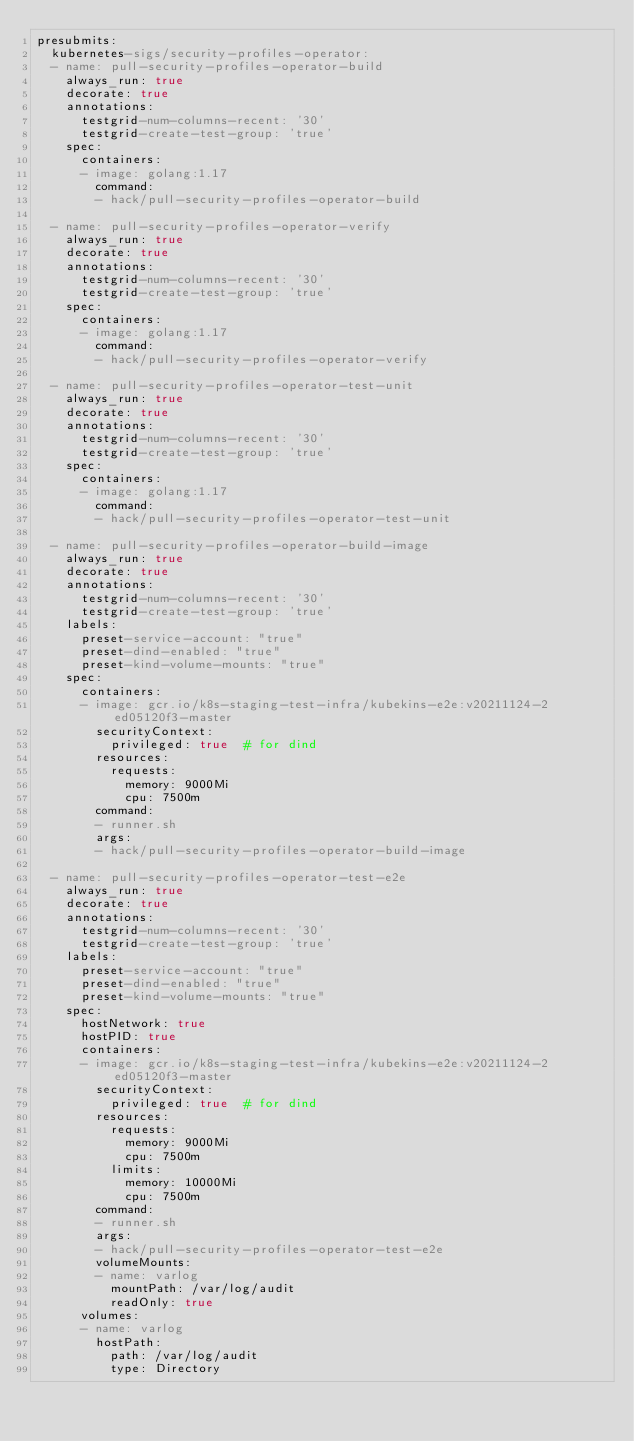Convert code to text. <code><loc_0><loc_0><loc_500><loc_500><_YAML_>presubmits:
  kubernetes-sigs/security-profiles-operator:
  - name: pull-security-profiles-operator-build
    always_run: true
    decorate: true
    annotations:
      testgrid-num-columns-recent: '30'
      testgrid-create-test-group: 'true'
    spec:
      containers:
      - image: golang:1.17
        command:
        - hack/pull-security-profiles-operator-build

  - name: pull-security-profiles-operator-verify
    always_run: true
    decorate: true
    annotations:
      testgrid-num-columns-recent: '30'
      testgrid-create-test-group: 'true'
    spec:
      containers:
      - image: golang:1.17
        command:
        - hack/pull-security-profiles-operator-verify

  - name: pull-security-profiles-operator-test-unit
    always_run: true
    decorate: true
    annotations:
      testgrid-num-columns-recent: '30'
      testgrid-create-test-group: 'true'
    spec:
      containers:
      - image: golang:1.17
        command:
        - hack/pull-security-profiles-operator-test-unit

  - name: pull-security-profiles-operator-build-image
    always_run: true
    decorate: true
    annotations:
      testgrid-num-columns-recent: '30'
      testgrid-create-test-group: 'true'
    labels:
      preset-service-account: "true"
      preset-dind-enabled: "true"
      preset-kind-volume-mounts: "true"
    spec:
      containers:
      - image: gcr.io/k8s-staging-test-infra/kubekins-e2e:v20211124-2ed05120f3-master
        securityContext:
          privileged: true  # for dind
        resources:
          requests:
            memory: 9000Mi
            cpu: 7500m
        command:
        - runner.sh
        args:
        - hack/pull-security-profiles-operator-build-image

  - name: pull-security-profiles-operator-test-e2e
    always_run: true
    decorate: true
    annotations:
      testgrid-num-columns-recent: '30'
      testgrid-create-test-group: 'true'
    labels:
      preset-service-account: "true"
      preset-dind-enabled: "true"
      preset-kind-volume-mounts: "true"
    spec:
      hostNetwork: true
      hostPID: true
      containers:
      - image: gcr.io/k8s-staging-test-infra/kubekins-e2e:v20211124-2ed05120f3-master
        securityContext:
          privileged: true  # for dind
        resources:
          requests:
            memory: 9000Mi
            cpu: 7500m
          limits:
            memory: 10000Mi
            cpu: 7500m
        command:
        - runner.sh
        args:
        - hack/pull-security-profiles-operator-test-e2e
        volumeMounts:
        - name: varlog
          mountPath: /var/log/audit
          readOnly: true
      volumes:
      - name: varlog
        hostPath:
          path: /var/log/audit
          type: Directory
</code> 